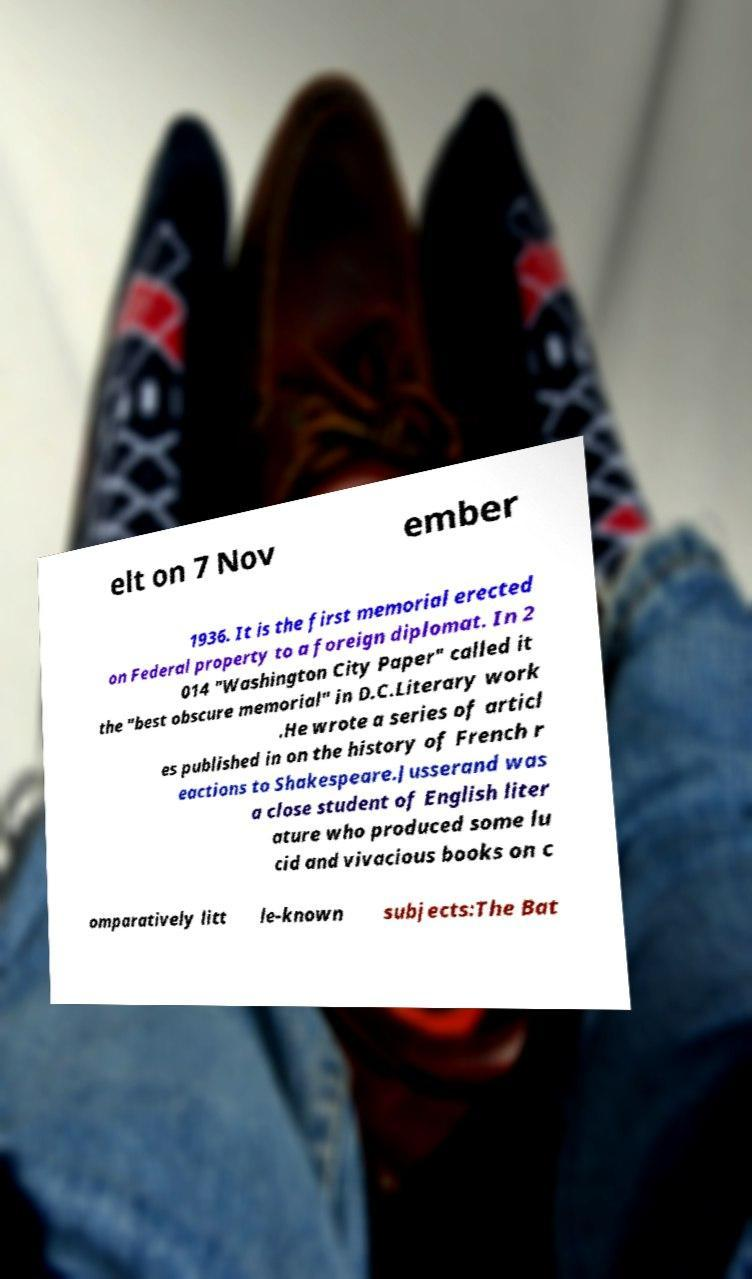Could you assist in decoding the text presented in this image and type it out clearly? elt on 7 Nov ember 1936. It is the first memorial erected on Federal property to a foreign diplomat. In 2 014 "Washington City Paper" called it the "best obscure memorial" in D.C.Literary work .He wrote a series of articl es published in on the history of French r eactions to Shakespeare.Jusserand was a close student of English liter ature who produced some lu cid and vivacious books on c omparatively litt le-known subjects:The Bat 